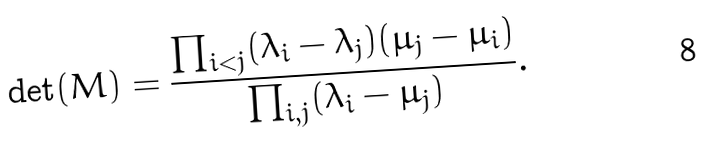Convert formula to latex. <formula><loc_0><loc_0><loc_500><loc_500>\det ( M ) = \frac { \prod _ { i < j } ( \lambda _ { i } - \lambda _ { j } ) ( \mu _ { j } - \mu _ { i } ) } { \prod _ { i , j } ( \lambda _ { i } - \mu _ { j } ) } .</formula> 